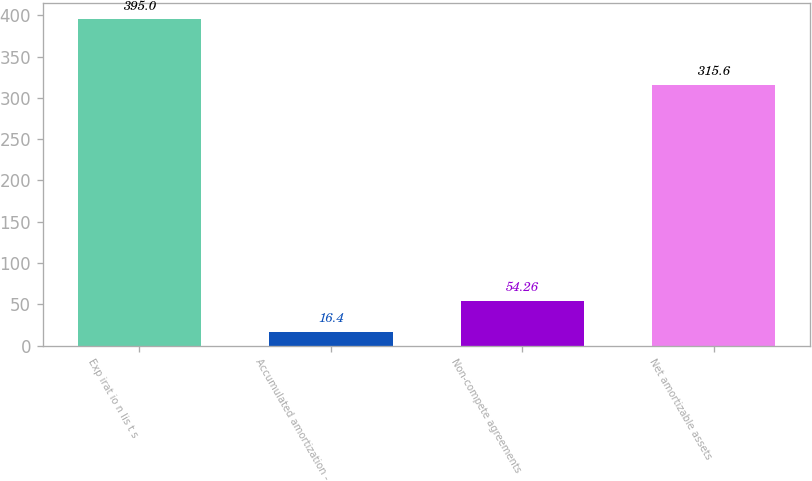Convert chart to OTSL. <chart><loc_0><loc_0><loc_500><loc_500><bar_chart><fcel>Exp irat io n lis t s<fcel>Accumulated amortization -<fcel>Non-compete agreements<fcel>Net amortizable assets<nl><fcel>395<fcel>16.4<fcel>54.26<fcel>315.6<nl></chart> 